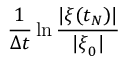<formula> <loc_0><loc_0><loc_500><loc_500>\frac { 1 } { \Delta t } \ln \frac { | { \boldsymbol \xi } ( t _ { N } ) | } { | { \boldsymbol \xi } _ { 0 } | }</formula> 